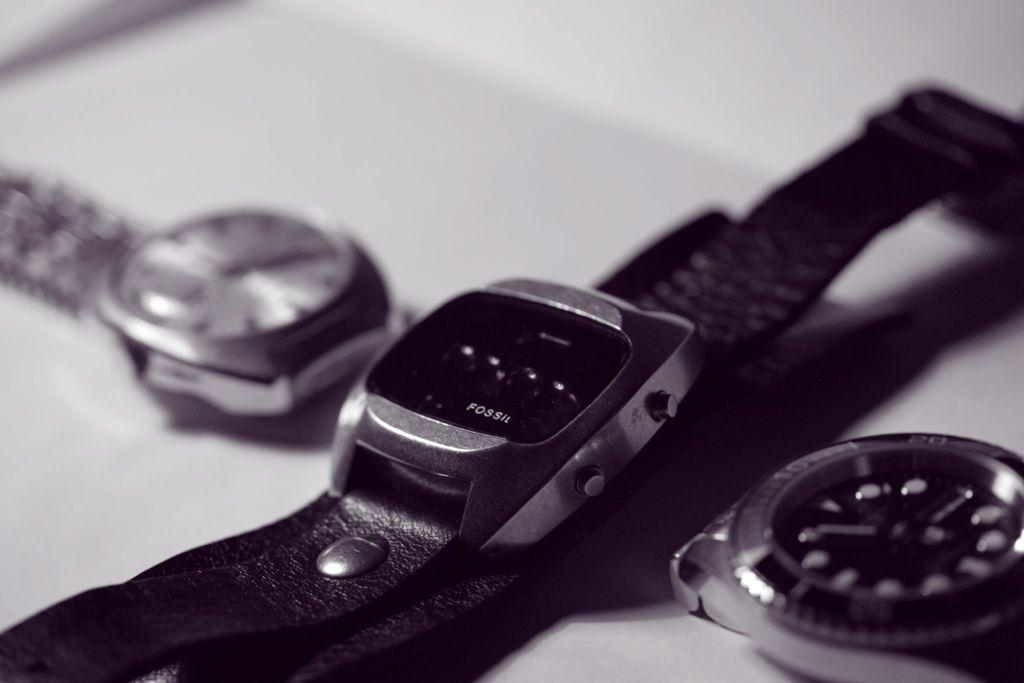Provide a one-sentence caption for the provided image. A black Fossil watch is laying on a table with 2 other watches. 